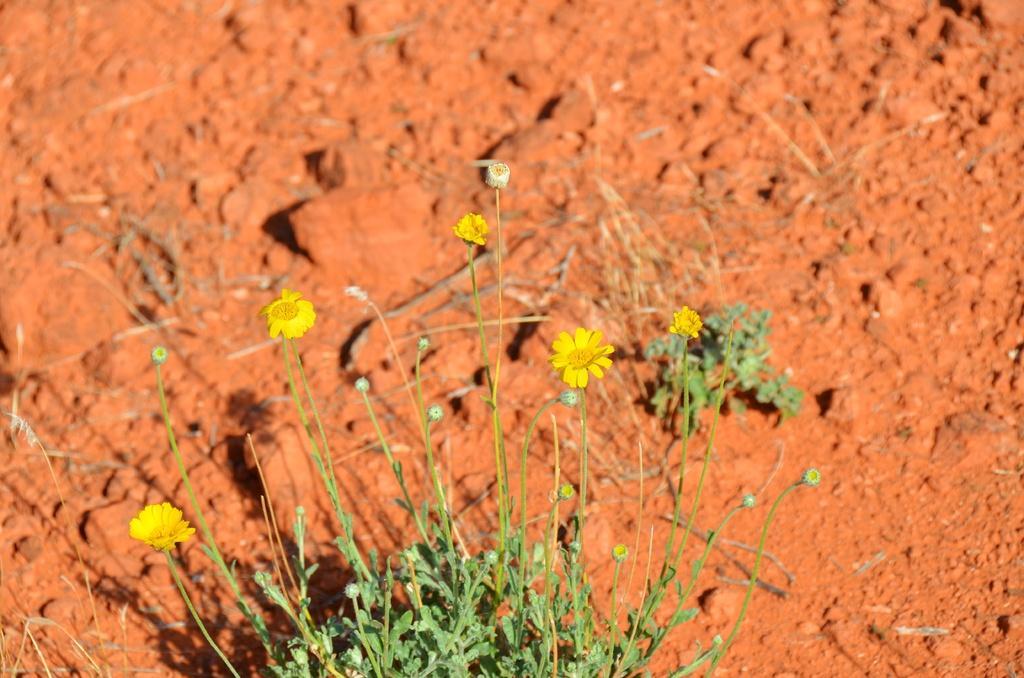Please provide a concise description of this image. At the bottom of the picture, we see the plant which has flowers and these flowers are in yellow color. In the background, we see the soil, which is brown in color. 